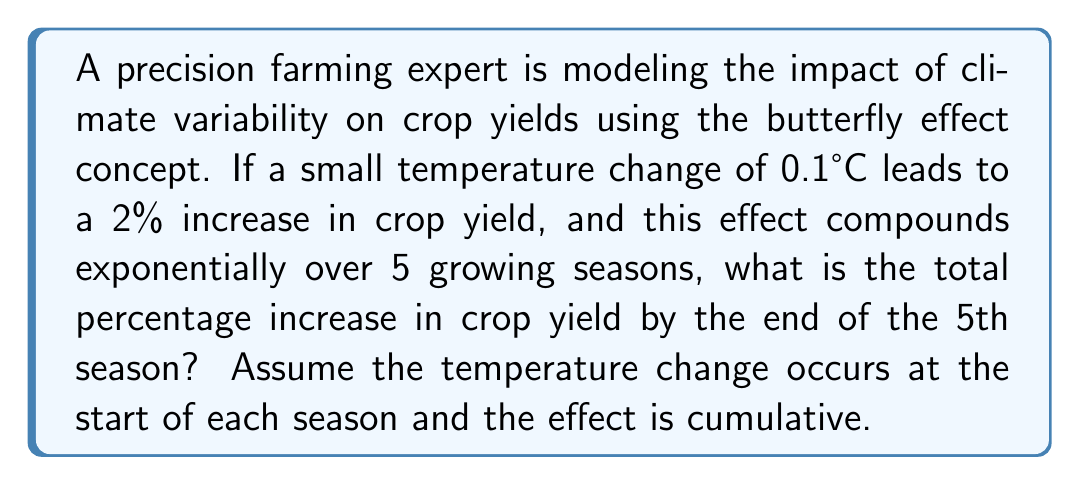Help me with this question. Let's approach this step-by-step:

1) We start with a 2% increase in the first season due to the 0.1°C temperature change.

2) The effect compounds exponentially, which means we multiply the yield by 1.02 each season.

3) To calculate the total effect over 5 seasons, we need to compound this 1.02 factor 5 times:

   $$(1.02)^5$$

4) Let's calculate this:
   $$(1.02)^5 = 1.1040808032$$

5) This means the yield after 5 seasons is 110.40808032% of the original yield.

6) To find the percentage increase, we subtract 1 (or 100%) from this value:

   $$1.1040808032 - 1 = 0.1040808032$$

7) Convert to a percentage by multiplying by 100:

   $$0.1040808032 \times 100 = 10.40808032\%$$

Therefore, the total percentage increase in crop yield by the end of the 5th season is approximately 10.41%.
Answer: 10.41% 